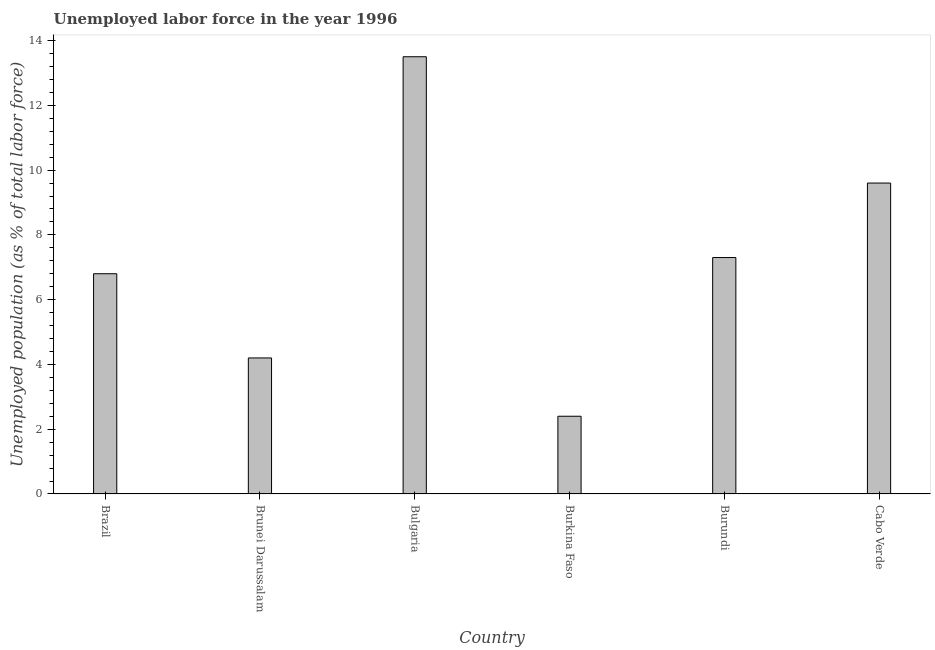Does the graph contain any zero values?
Give a very brief answer. No. Does the graph contain grids?
Give a very brief answer. No. What is the title of the graph?
Provide a succinct answer. Unemployed labor force in the year 1996. What is the label or title of the Y-axis?
Offer a very short reply. Unemployed population (as % of total labor force). What is the total unemployed population in Burundi?
Provide a short and direct response. 7.3. Across all countries, what is the minimum total unemployed population?
Ensure brevity in your answer.  2.4. In which country was the total unemployed population minimum?
Ensure brevity in your answer.  Burkina Faso. What is the sum of the total unemployed population?
Provide a short and direct response. 43.8. What is the difference between the total unemployed population in Brazil and Burkina Faso?
Offer a terse response. 4.4. What is the median total unemployed population?
Keep it short and to the point. 7.05. In how many countries, is the total unemployed population greater than 7.2 %?
Offer a terse response. 3. What is the ratio of the total unemployed population in Brunei Darussalam to that in Cabo Verde?
Provide a short and direct response. 0.44. Is the sum of the total unemployed population in Bulgaria and Burkina Faso greater than the maximum total unemployed population across all countries?
Keep it short and to the point. Yes. What is the difference between the highest and the lowest total unemployed population?
Your answer should be very brief. 11.1. How many bars are there?
Offer a very short reply. 6. How many countries are there in the graph?
Provide a short and direct response. 6. Are the values on the major ticks of Y-axis written in scientific E-notation?
Keep it short and to the point. No. What is the Unemployed population (as % of total labor force) of Brazil?
Ensure brevity in your answer.  6.8. What is the Unemployed population (as % of total labor force) in Brunei Darussalam?
Give a very brief answer. 4.2. What is the Unemployed population (as % of total labor force) of Burkina Faso?
Offer a very short reply. 2.4. What is the Unemployed population (as % of total labor force) of Burundi?
Give a very brief answer. 7.3. What is the Unemployed population (as % of total labor force) in Cabo Verde?
Give a very brief answer. 9.6. What is the difference between the Unemployed population (as % of total labor force) in Brazil and Brunei Darussalam?
Make the answer very short. 2.6. What is the difference between the Unemployed population (as % of total labor force) in Brazil and Bulgaria?
Offer a terse response. -6.7. What is the difference between the Unemployed population (as % of total labor force) in Brazil and Burkina Faso?
Offer a terse response. 4.4. What is the difference between the Unemployed population (as % of total labor force) in Brunei Darussalam and Bulgaria?
Your answer should be very brief. -9.3. What is the difference between the Unemployed population (as % of total labor force) in Brunei Darussalam and Burkina Faso?
Make the answer very short. 1.8. What is the difference between the Unemployed population (as % of total labor force) in Brunei Darussalam and Burundi?
Provide a succinct answer. -3.1. What is the difference between the Unemployed population (as % of total labor force) in Brunei Darussalam and Cabo Verde?
Provide a short and direct response. -5.4. What is the difference between the Unemployed population (as % of total labor force) in Bulgaria and Burkina Faso?
Ensure brevity in your answer.  11.1. What is the difference between the Unemployed population (as % of total labor force) in Bulgaria and Cabo Verde?
Your answer should be very brief. 3.9. What is the difference between the Unemployed population (as % of total labor force) in Burkina Faso and Burundi?
Ensure brevity in your answer.  -4.9. What is the ratio of the Unemployed population (as % of total labor force) in Brazil to that in Brunei Darussalam?
Your answer should be very brief. 1.62. What is the ratio of the Unemployed population (as % of total labor force) in Brazil to that in Bulgaria?
Keep it short and to the point. 0.5. What is the ratio of the Unemployed population (as % of total labor force) in Brazil to that in Burkina Faso?
Give a very brief answer. 2.83. What is the ratio of the Unemployed population (as % of total labor force) in Brazil to that in Burundi?
Your answer should be very brief. 0.93. What is the ratio of the Unemployed population (as % of total labor force) in Brazil to that in Cabo Verde?
Make the answer very short. 0.71. What is the ratio of the Unemployed population (as % of total labor force) in Brunei Darussalam to that in Bulgaria?
Ensure brevity in your answer.  0.31. What is the ratio of the Unemployed population (as % of total labor force) in Brunei Darussalam to that in Burkina Faso?
Provide a succinct answer. 1.75. What is the ratio of the Unemployed population (as % of total labor force) in Brunei Darussalam to that in Burundi?
Give a very brief answer. 0.57. What is the ratio of the Unemployed population (as % of total labor force) in Brunei Darussalam to that in Cabo Verde?
Your response must be concise. 0.44. What is the ratio of the Unemployed population (as % of total labor force) in Bulgaria to that in Burkina Faso?
Keep it short and to the point. 5.62. What is the ratio of the Unemployed population (as % of total labor force) in Bulgaria to that in Burundi?
Offer a very short reply. 1.85. What is the ratio of the Unemployed population (as % of total labor force) in Bulgaria to that in Cabo Verde?
Ensure brevity in your answer.  1.41. What is the ratio of the Unemployed population (as % of total labor force) in Burkina Faso to that in Burundi?
Your response must be concise. 0.33. What is the ratio of the Unemployed population (as % of total labor force) in Burkina Faso to that in Cabo Verde?
Offer a very short reply. 0.25. What is the ratio of the Unemployed population (as % of total labor force) in Burundi to that in Cabo Verde?
Provide a short and direct response. 0.76. 